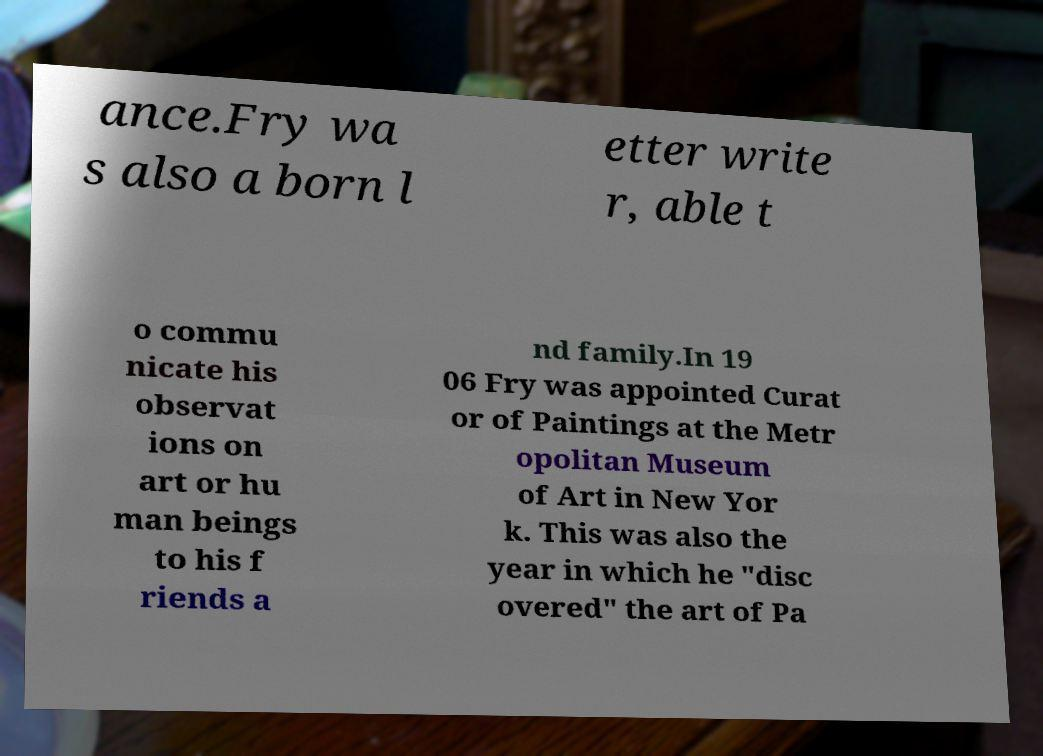Please read and relay the text visible in this image. What does it say? ance.Fry wa s also a born l etter write r, able t o commu nicate his observat ions on art or hu man beings to his f riends a nd family.In 19 06 Fry was appointed Curat or of Paintings at the Metr opolitan Museum of Art in New Yor k. This was also the year in which he "disc overed" the art of Pa 